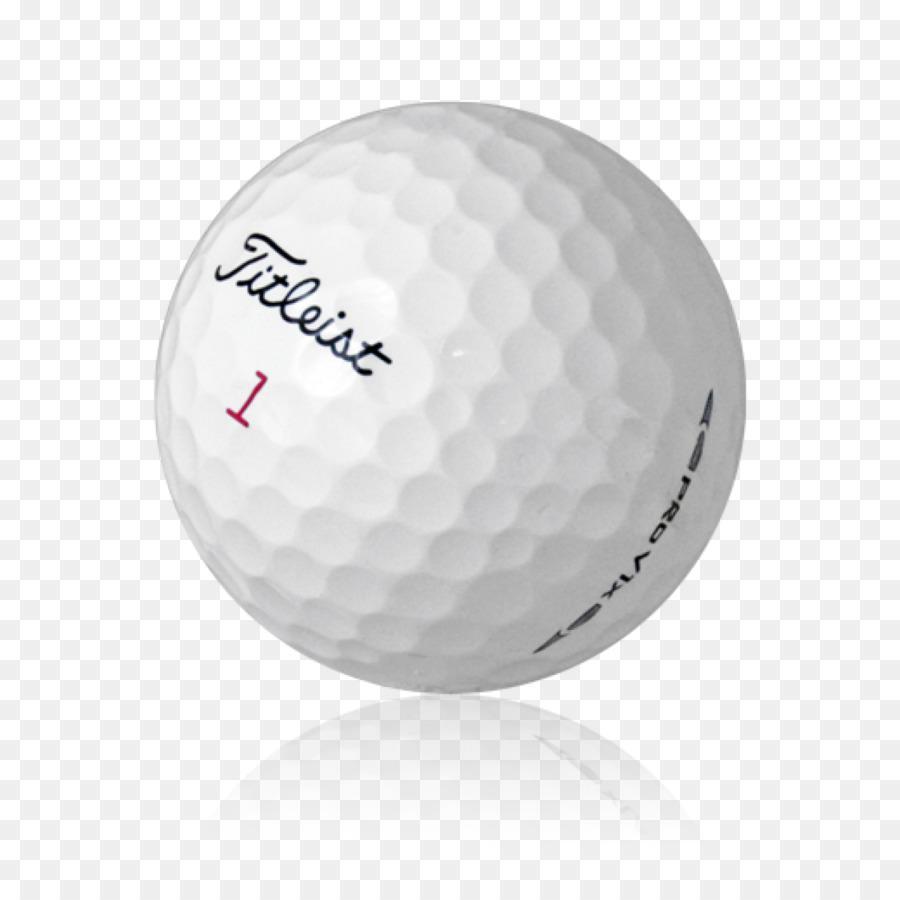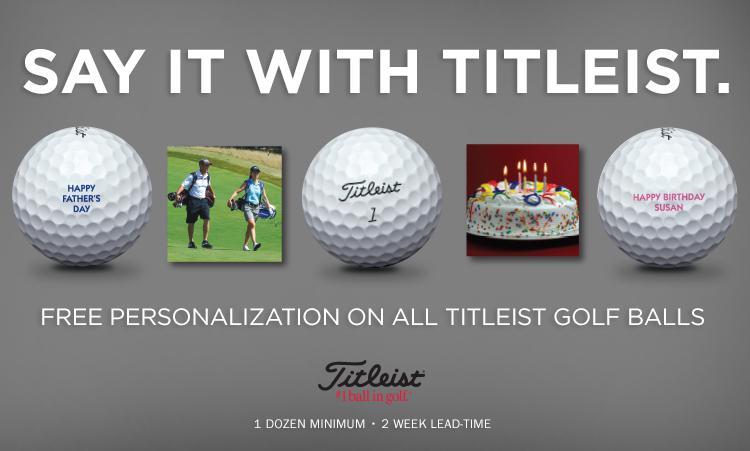The first image is the image on the left, the second image is the image on the right. Evaluate the accuracy of this statement regarding the images: "The left and right image contains the same number of playable golf clubs.". Is it true? Answer yes or no. No. The first image is the image on the left, the second image is the image on the right. Given the left and right images, does the statement "The left image is a golf ball with a flower on it." hold true? Answer yes or no. No. 